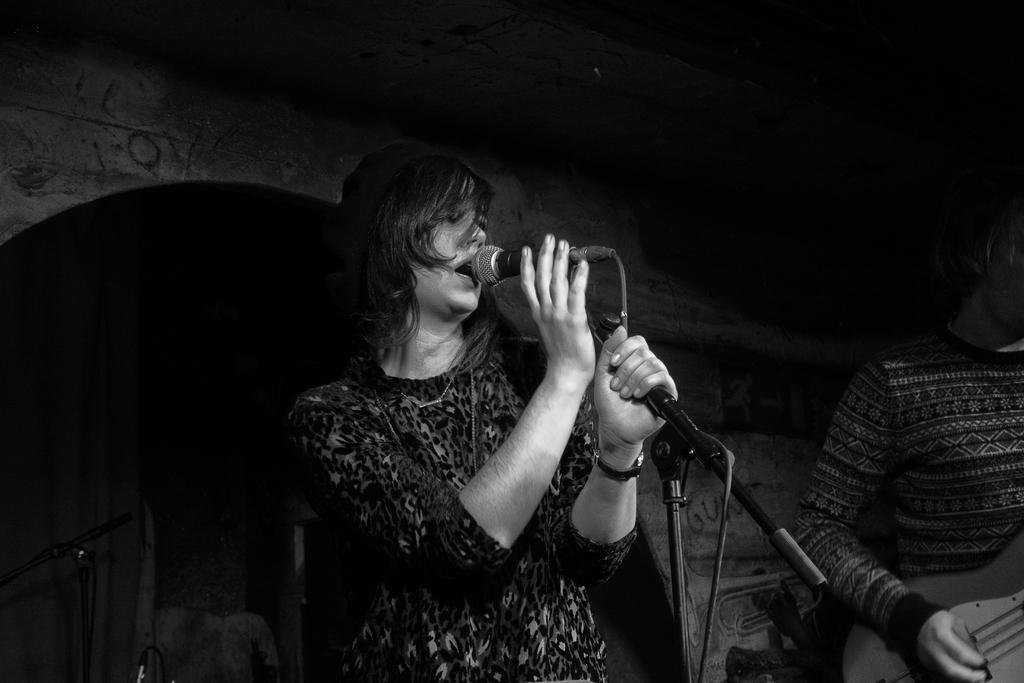How would you summarize this image in a sentence or two? There are two people. One is women and another one is man. She is holding a mic. She is singing and she is wearing a watch. The backside of the stage is completely dark. 